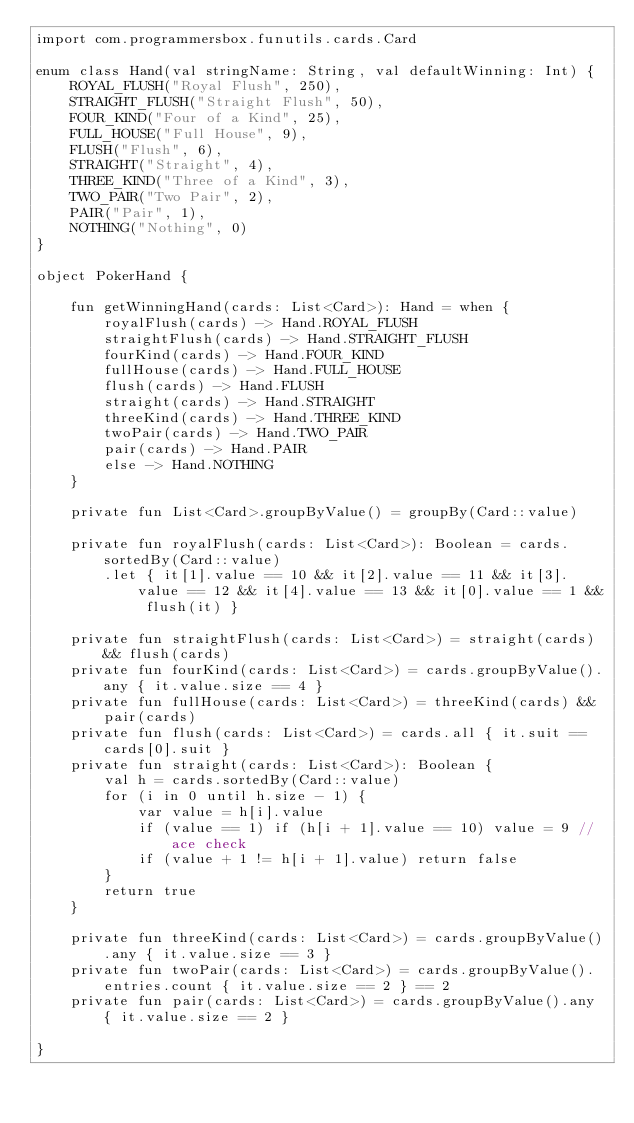Convert code to text. <code><loc_0><loc_0><loc_500><loc_500><_Kotlin_>import com.programmersbox.funutils.cards.Card

enum class Hand(val stringName: String, val defaultWinning: Int) {
    ROYAL_FLUSH("Royal Flush", 250),
    STRAIGHT_FLUSH("Straight Flush", 50),
    FOUR_KIND("Four of a Kind", 25),
    FULL_HOUSE("Full House", 9),
    FLUSH("Flush", 6),
    STRAIGHT("Straight", 4),
    THREE_KIND("Three of a Kind", 3),
    TWO_PAIR("Two Pair", 2),
    PAIR("Pair", 1),
    NOTHING("Nothing", 0)
}

object PokerHand {

    fun getWinningHand(cards: List<Card>): Hand = when {
        royalFlush(cards) -> Hand.ROYAL_FLUSH
        straightFlush(cards) -> Hand.STRAIGHT_FLUSH
        fourKind(cards) -> Hand.FOUR_KIND
        fullHouse(cards) -> Hand.FULL_HOUSE
        flush(cards) -> Hand.FLUSH
        straight(cards) -> Hand.STRAIGHT
        threeKind(cards) -> Hand.THREE_KIND
        twoPair(cards) -> Hand.TWO_PAIR
        pair(cards) -> Hand.PAIR
        else -> Hand.NOTHING
    }

    private fun List<Card>.groupByValue() = groupBy(Card::value)

    private fun royalFlush(cards: List<Card>): Boolean = cards.sortedBy(Card::value)
        .let { it[1].value == 10 && it[2].value == 11 && it[3].value == 12 && it[4].value == 13 && it[0].value == 1 && flush(it) }

    private fun straightFlush(cards: List<Card>) = straight(cards) && flush(cards)
    private fun fourKind(cards: List<Card>) = cards.groupByValue().any { it.value.size == 4 }
    private fun fullHouse(cards: List<Card>) = threeKind(cards) && pair(cards)
    private fun flush(cards: List<Card>) = cards.all { it.suit == cards[0].suit }
    private fun straight(cards: List<Card>): Boolean {
        val h = cards.sortedBy(Card::value)
        for (i in 0 until h.size - 1) {
            var value = h[i].value
            if (value == 1) if (h[i + 1].value == 10) value = 9 //ace check
            if (value + 1 != h[i + 1].value) return false
        }
        return true
    }

    private fun threeKind(cards: List<Card>) = cards.groupByValue().any { it.value.size == 3 }
    private fun twoPair(cards: List<Card>) = cards.groupByValue().entries.count { it.value.size == 2 } == 2
    private fun pair(cards: List<Card>) = cards.groupByValue().any { it.value.size == 2 }

}</code> 